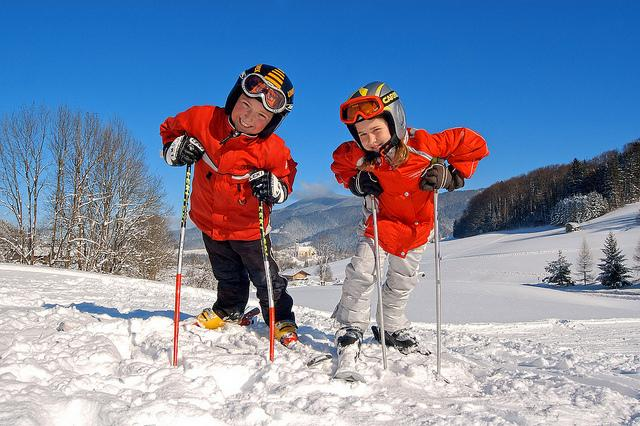Where is most of the kids weight? Please explain your reasoning. on skis. They are both leaning forward onto their poles and putting their weight on them. 